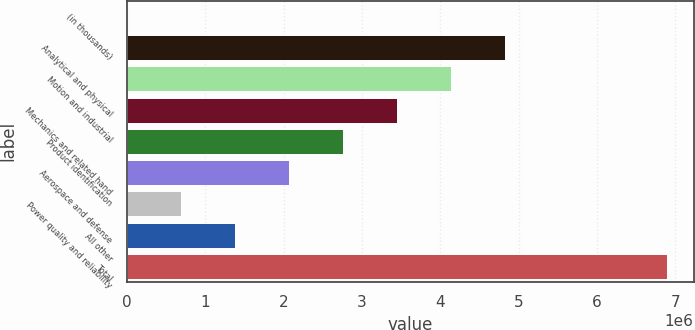Convert chart. <chart><loc_0><loc_0><loc_500><loc_500><bar_chart><fcel>(in thousands)<fcel>Analytical and physical<fcel>Motion and industrial<fcel>Mechanics and related hand<fcel>Product identification<fcel>Aerospace and defense<fcel>Power quality and reliability<fcel>All other<fcel>Total<nl><fcel>2004<fcel>4.82311e+06<fcel>4.13438e+06<fcel>3.44565e+06<fcel>2.75692e+06<fcel>2.06819e+06<fcel>690734<fcel>1.37946e+06<fcel>6.8893e+06<nl></chart> 